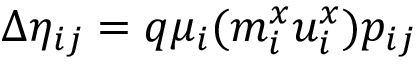<formula> <loc_0><loc_0><loc_500><loc_500>\Delta \eta _ { i j } = q \mu _ { i } ( m _ { i } ^ { x } u _ { i } ^ { x } ) p _ { i j }</formula> 